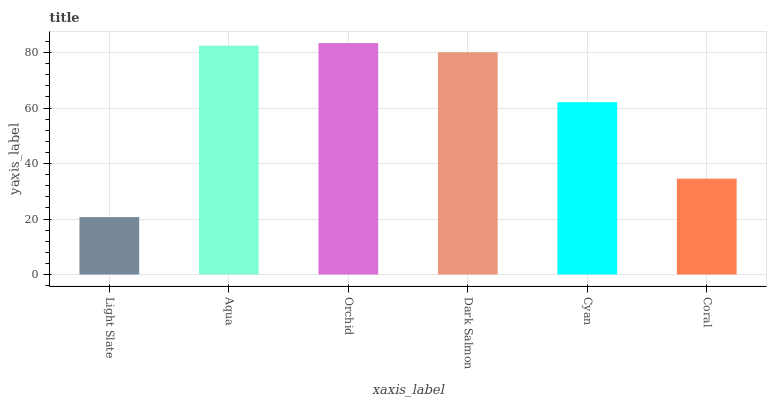Is Light Slate the minimum?
Answer yes or no. Yes. Is Orchid the maximum?
Answer yes or no. Yes. Is Aqua the minimum?
Answer yes or no. No. Is Aqua the maximum?
Answer yes or no. No. Is Aqua greater than Light Slate?
Answer yes or no. Yes. Is Light Slate less than Aqua?
Answer yes or no. Yes. Is Light Slate greater than Aqua?
Answer yes or no. No. Is Aqua less than Light Slate?
Answer yes or no. No. Is Dark Salmon the high median?
Answer yes or no. Yes. Is Cyan the low median?
Answer yes or no. Yes. Is Coral the high median?
Answer yes or no. No. Is Aqua the low median?
Answer yes or no. No. 